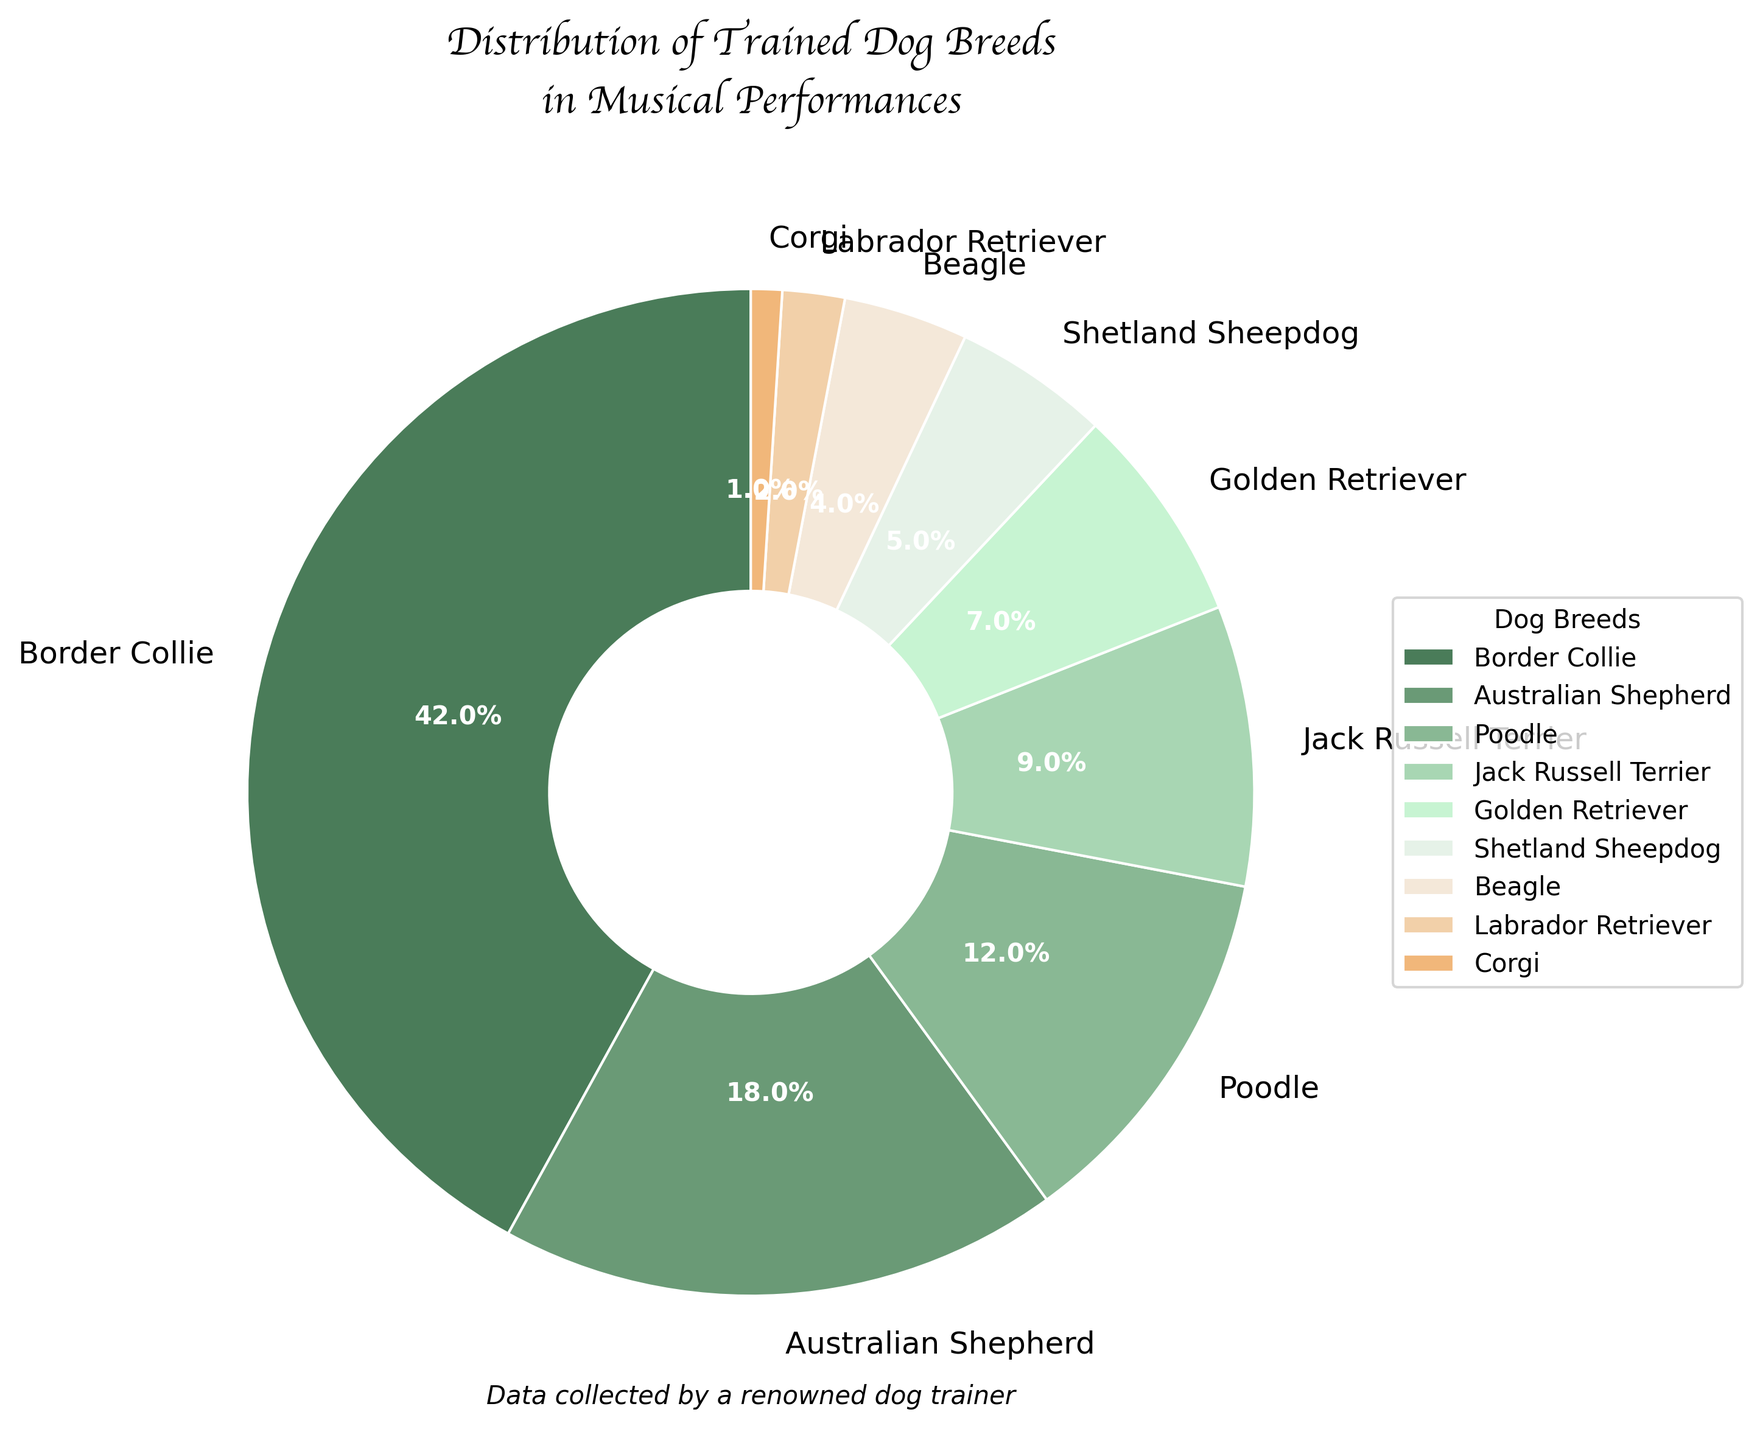What's the most common dog breed used in musical performances? Border Collies make up 42% of the trained dogs in musical performances, which is the highest among all breeds shown in the chart.
Answer: Border Collie Which dog breed is the least common in musical performances? The breed with the smallest percentage in the chart is Corgi, which makes up 1% of the trained dogs in musical performances.
Answer: Corgi What percentage of trained dogs in musical performances are either Beagles or Labrador Retrievers? Beagles account for 4% and Labrador Retrievers account for 2%. Adding these percentages together, 4% + 2% = 6%.
Answer: 6% How many times more common are Border Collies compared to Corgis in musical performances? Border Collies make up 42%, while Corgis make up 1%. To find how many times more common Border Collies are, divide 42 by 1. 42 / 1 = 42.
Answer: 42 times Which two breeds together make up over a quarter of the trained dogs in musical performances? Australian Shepherds make up 18% and Poodles make up 12%. Adding these together gives 18% + 12% = 30%, which is over a quarter (25%).
Answer: Australian Shepherds and Poodles Are Shetland Sheepdogs or Jack Russell Terriers more common in musical performances? Shetland Sheepdogs make up 5%, while Jack Russell Terriers make up 9% of the performances. Therefore, Jack Russell Terriers are more common.
Answer: Jack Russell Terriers What is the combined percentage of the three least common dog breeds in musical performances? The three least common breeds are Labrador Retriever (2%), Corgi (1%), and Beagle (4%). Adding these together, 2% + 1% + 4% = 7%.
Answer: 7% How much more common are Australian Shepherds than Golden Retrievers in musical performances? Australian Shepherds make up 18%, while Golden Retrievers make up 7%. To find out how much more common they are, subtract the percentage of Golden Retrievers from Australian Shepherds: 18% - 7% = 11%.
Answer: 11% What is the difference in percentage between the most and least common breeds used in musical performances? The most common breed, Border Collie, makes up 42%, while the least common breed, Corgi, makes up 1%. The difference is 42% - 1% = 41%.
Answer: 41% Which breed occupies the largest segment in the lightest green color? The lightest green color in the pie chart corresponds to Poodles, which make up 12% of the trained dogs in musical performances.
Answer: Poodle 